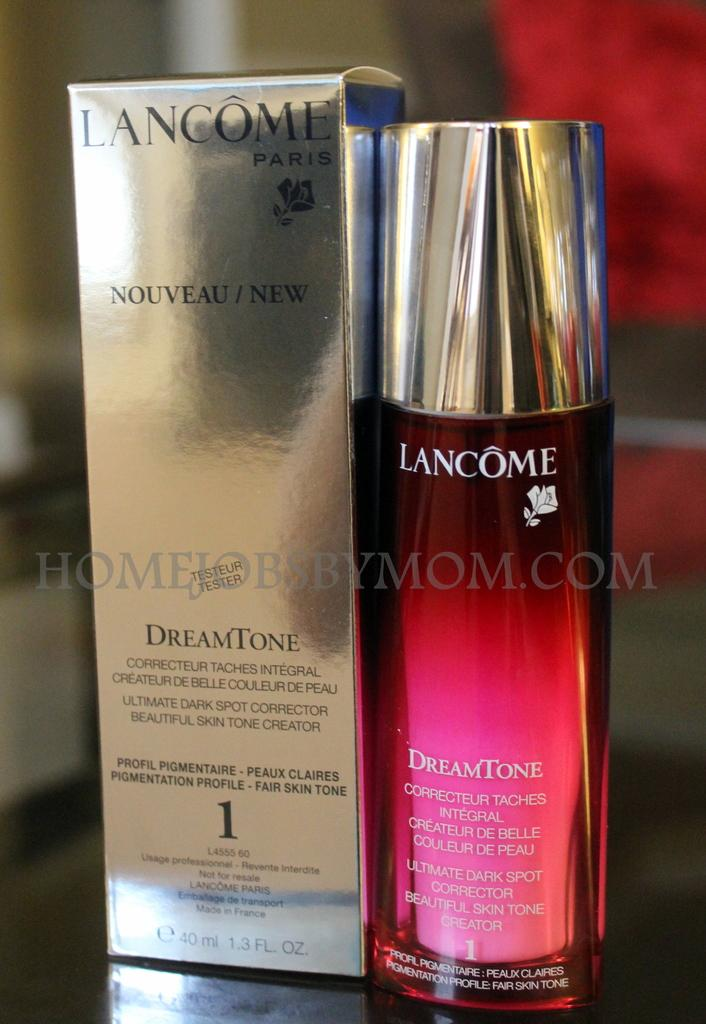<image>
Provide a brief description of the given image. A bottle of Lancome Dream Tone skin toner stands next to its attractive silver packaging. 